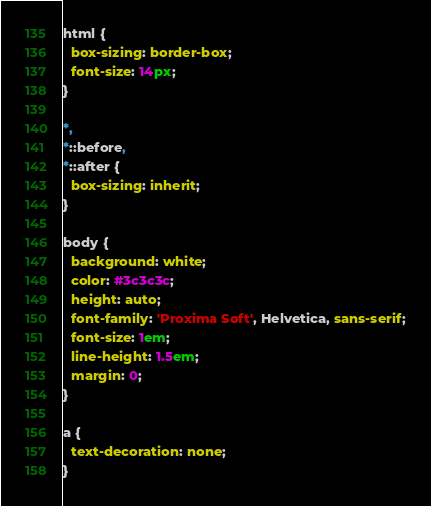Convert code to text. <code><loc_0><loc_0><loc_500><loc_500><_CSS_>html {
  box-sizing: border-box;
  font-size: 14px;
}

*,
*::before,
*::after {
  box-sizing: inherit;
}

body {
  background: white;
  color: #3c3c3c;
  height: auto;
  font-family: 'Proxima Soft', Helvetica, sans-serif;
  font-size: 1em;
  line-height: 1.5em;
  margin: 0;
}

a {
  text-decoration: none;
}
</code> 